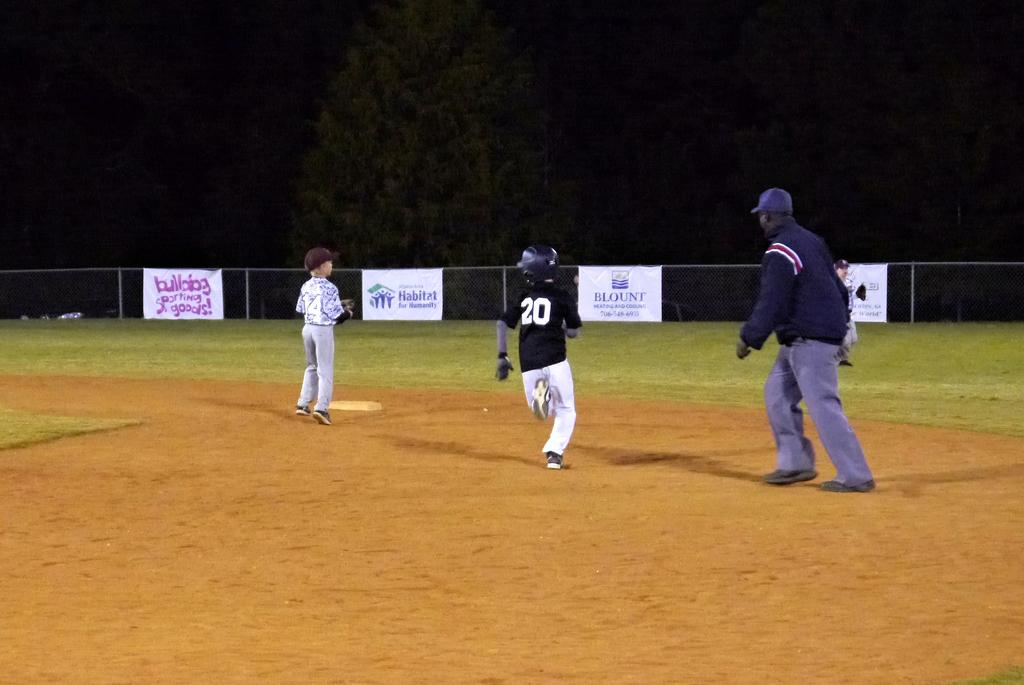<image>
Write a terse but informative summary of the picture. the number 20 is on the black jersey of a person 